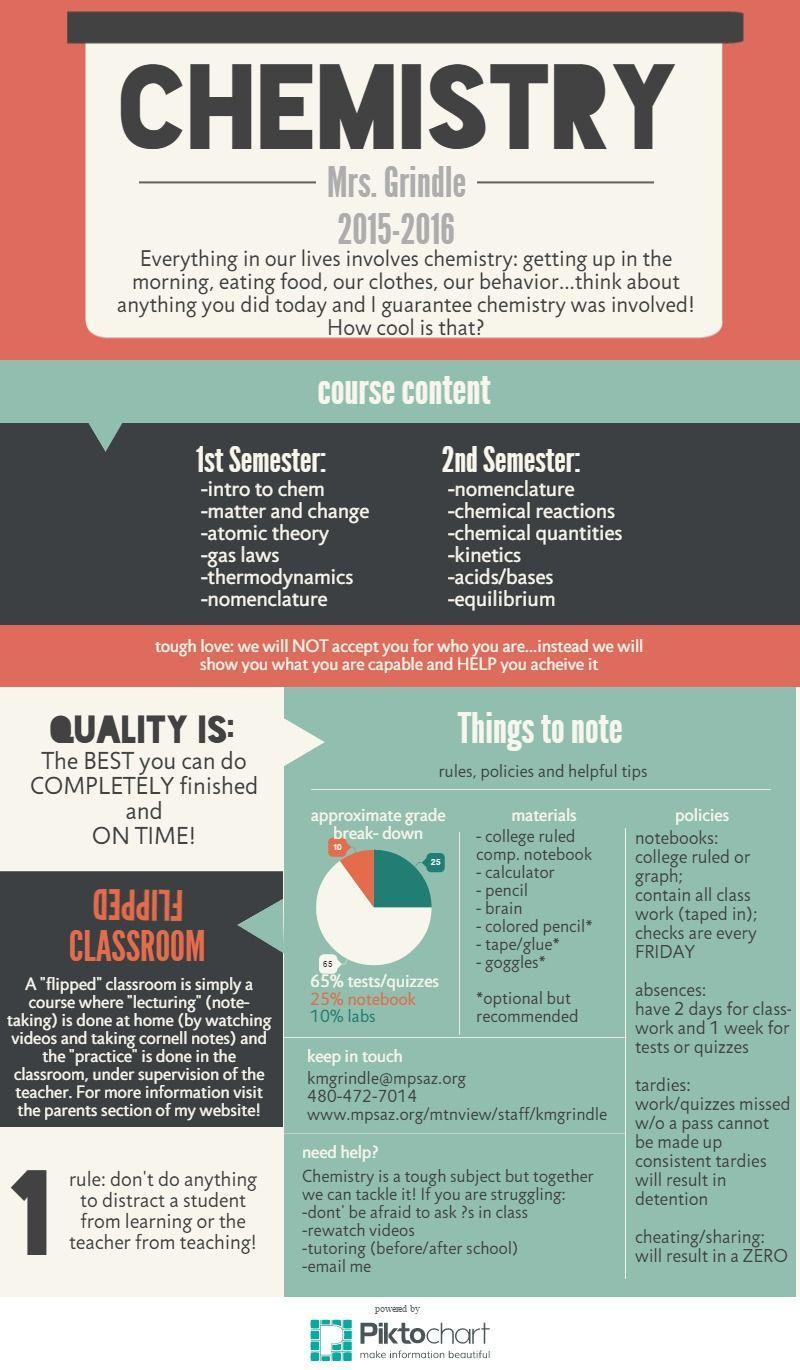What percentage of labs and notebooks together determine the grade?
Answer the question with a short phrase. 35% What percentage of tests and notebooks together determine the grade? 90% 